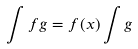<formula> <loc_0><loc_0><loc_500><loc_500>\int f g = f ( x ) \int g</formula> 